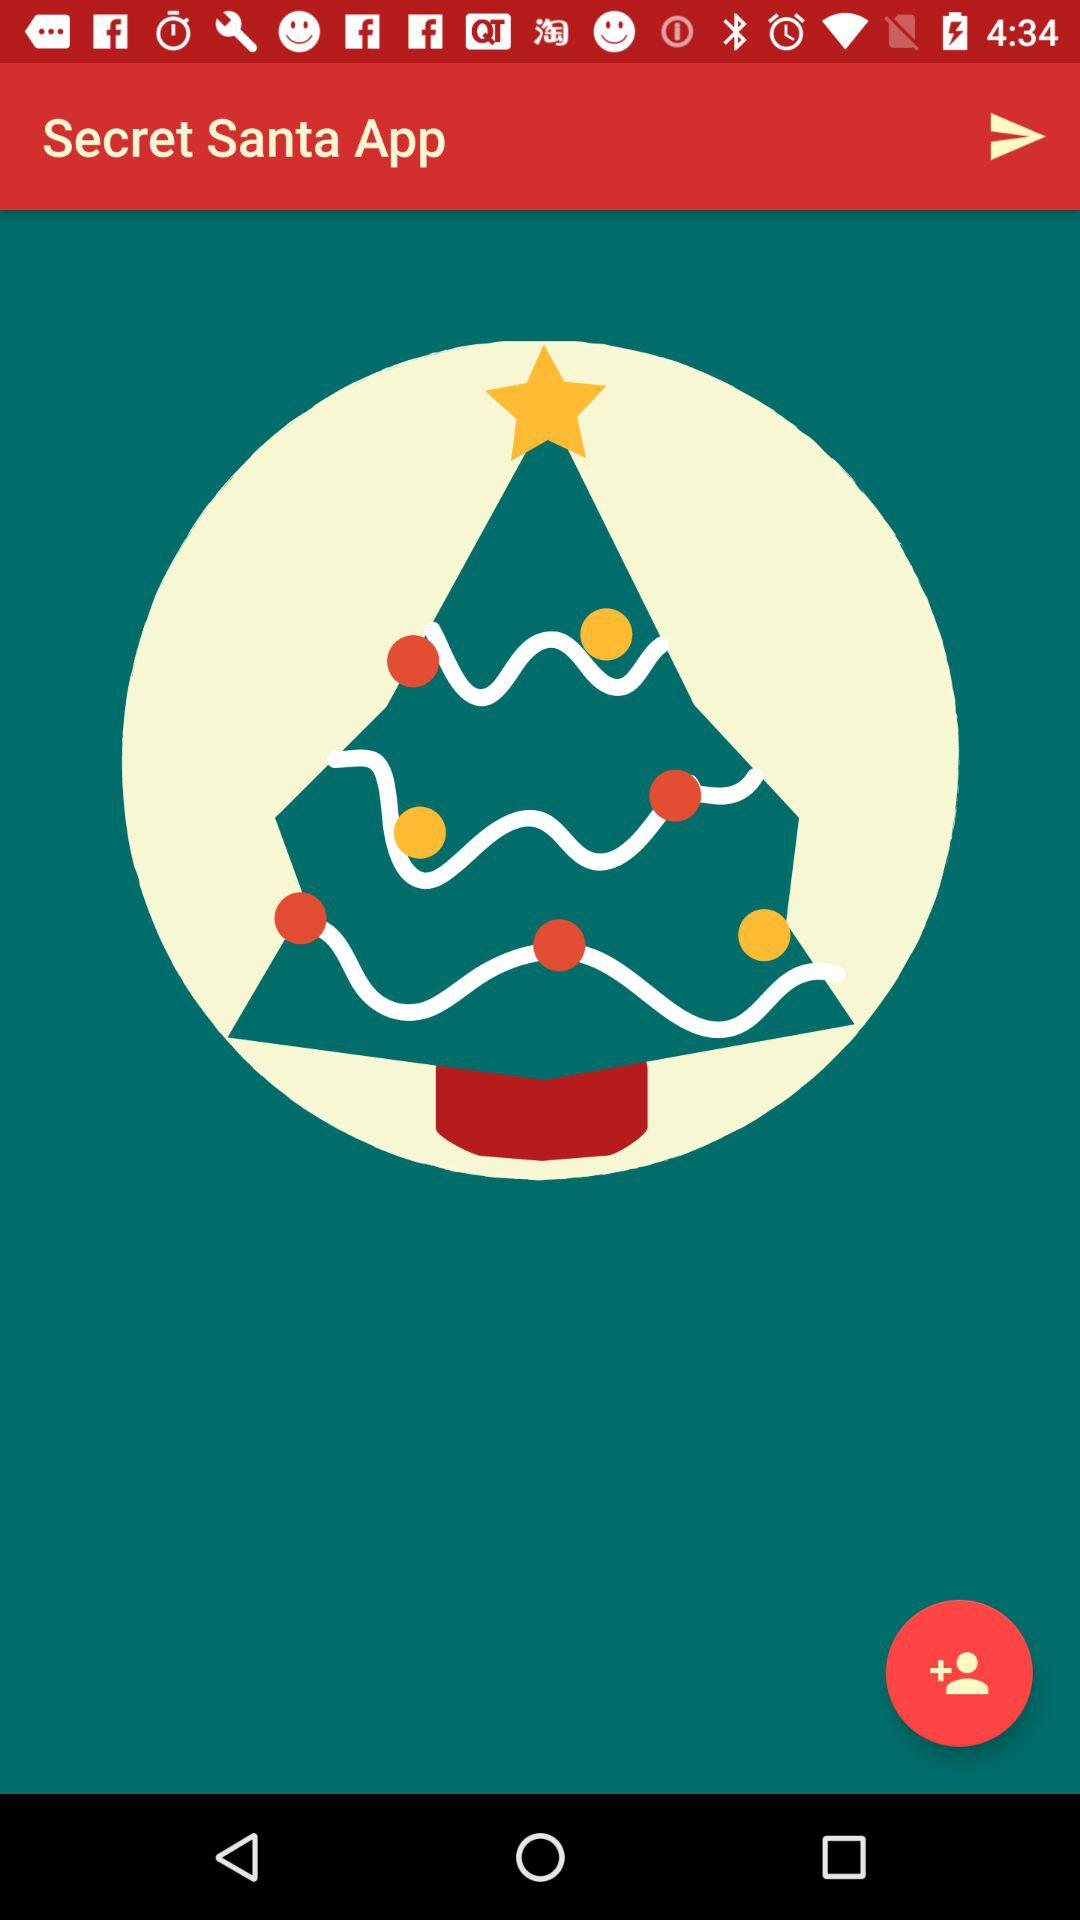What is the application name? The application name is "Secret Santa App". 